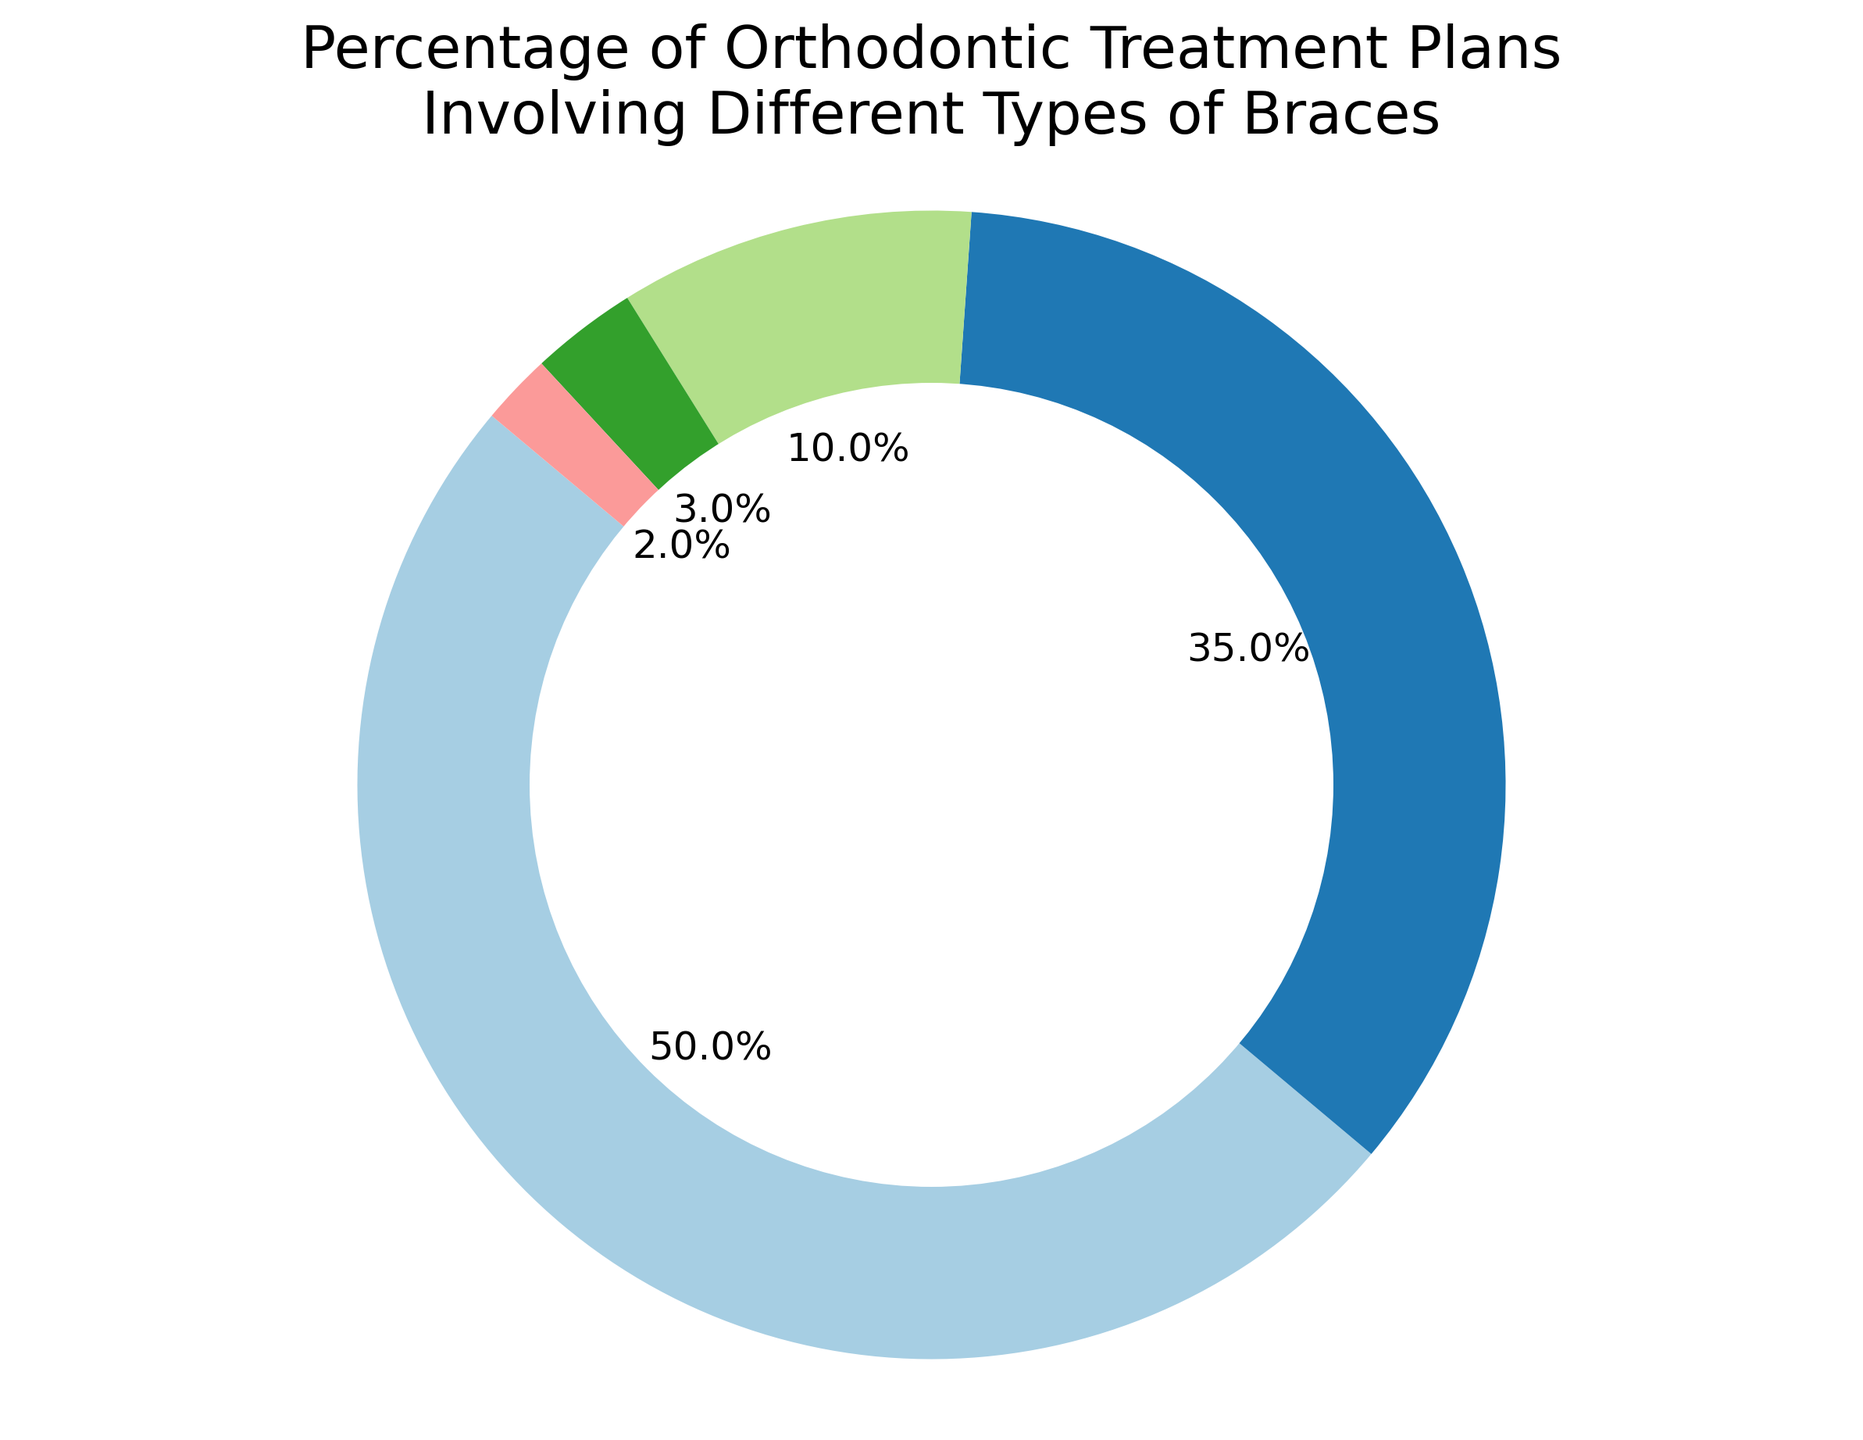Which type of braces is most commonly used in the orthodontic treatment plans? The figure shows that Traditional Braces have the highest percentage, comprising 50% of the treatment plans.
Answer: Traditional Braces Which type of braces is least commonly used according to the pie chart? The figure indicates that Ceramic Braces have the lowest percentage, making up only 2% of the treatment plans.
Answer: Ceramic Braces What percentage of orthodontic treatment plans involves either Clear Aligners or Lingual Braces? Clear Aligners account for 35% and Lingual Braces account for 10%. Adding these percentages together: 35% + 10% = 45%.
Answer: 45% Do Self-Ligating Braces and Ceramic Braces combined account for more than 5% of the treatment plans? Self-Ligating Braces are 3% and Ceramic Braces are 2%. Adding these together: 3% + 2% = 5%. So they do not account for more than 5%.
Answer: No How much greater is the percentage of Traditional Braces compared to Lingual Braces? Traditional Braces account for 50% and Lingual Braces account for 10%. Subtracting these: 50% - 10% = 40%.
Answer: 40% Which type of braces has the second highest percentage in the treatment plans? The figure shows that Clear Aligners are the second most common type, making up 35% of the treatment plans.
Answer: Clear Aligners What is the combined percentage of the two least commonly used types of braces? The two least common types are Ceramic Braces (2%) and Self-Ligating Braces (3%). Adding these: 2% + 3% = 5%.
Answer: 5% Is the percentage of Clear Aligners greater than the combined percentage of Lingual Braces and Self-Ligating Braces? Clear Aligners account for 35%. Lingual Braces and Self-Ligating Braces together account for 10% + 3% = 13%. Since 35% > 13%, Clear Aligners have a greater percentage.
Answer: Yes Which types of braces are represented in the pie chart using various colors? The pie chart uses different colors to represent each type: Traditional Braces, Clear Aligners, Lingual Braces, Self-Ligating Braces, and Ceramic Braces.
Answer: Traditional Braces, Clear Aligners, Lingual Braces, Self-Ligating Braces, Ceramic Braces 